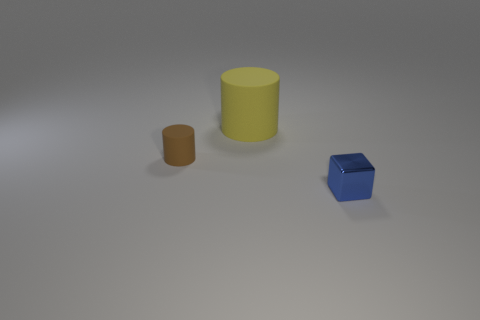Add 1 small rubber cylinders. How many objects exist? 4 Subtract all cylinders. How many objects are left? 1 Subtract 2 cylinders. How many cylinders are left? 0 Subtract all yellow things. Subtract all blocks. How many objects are left? 1 Add 1 matte cylinders. How many matte cylinders are left? 3 Add 2 big purple spheres. How many big purple spheres exist? 2 Subtract 0 gray blocks. How many objects are left? 3 Subtract all red cubes. Subtract all brown cylinders. How many cubes are left? 1 Subtract all gray balls. How many purple cubes are left? 0 